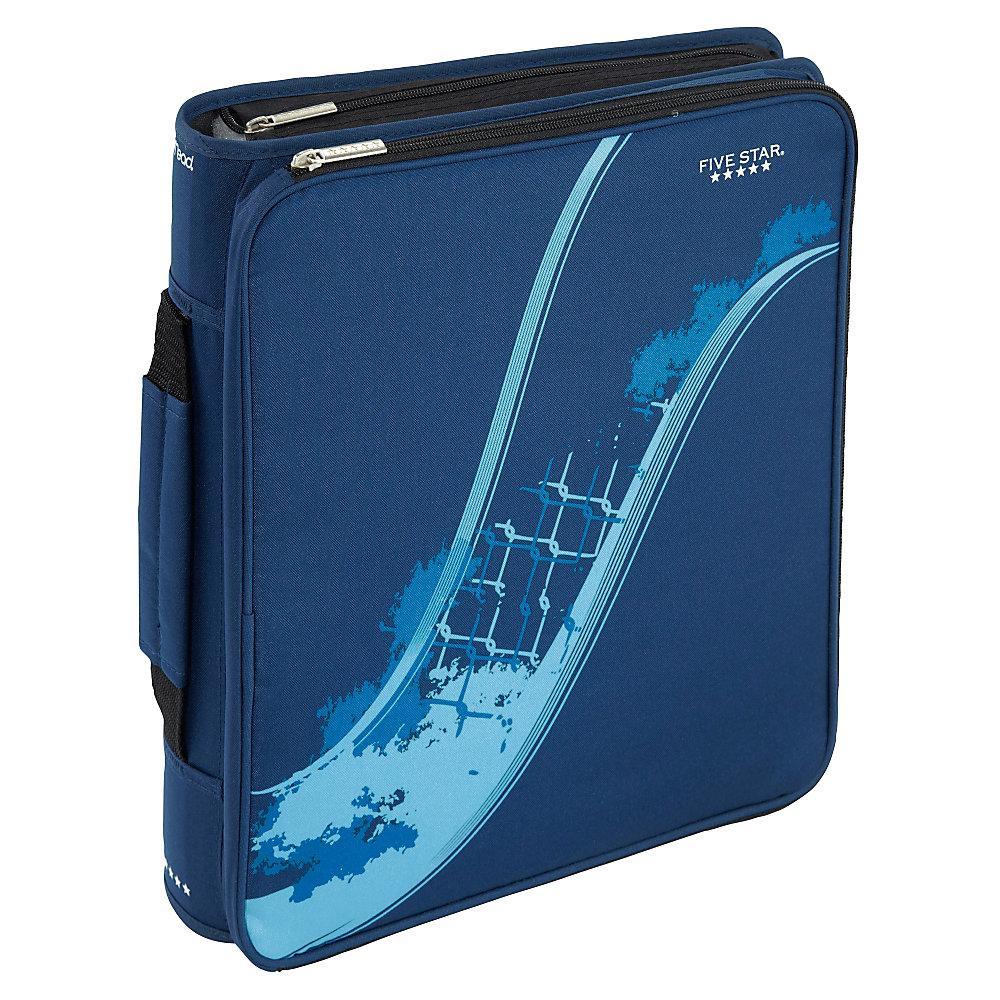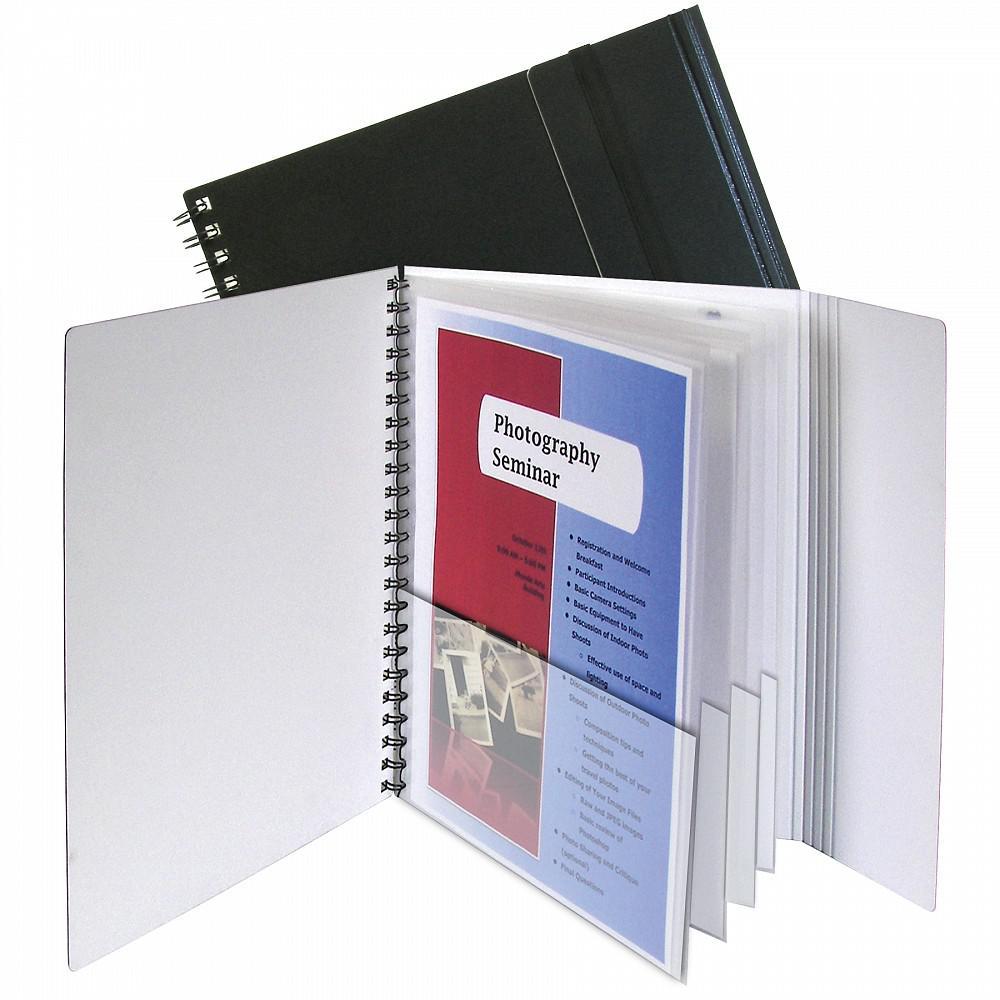The first image is the image on the left, the second image is the image on the right. Analyze the images presented: Is the assertion "An image shows a binder with three metal rings lying open and completely flat on a surface, containing pages that aren't in the rings." valid? Answer yes or no. No. The first image is the image on the left, the second image is the image on the right. Evaluate the accuracy of this statement regarding the images: "The image to the right displays an open binder, and not just a notebook.". Is it true? Answer yes or no. Yes. 